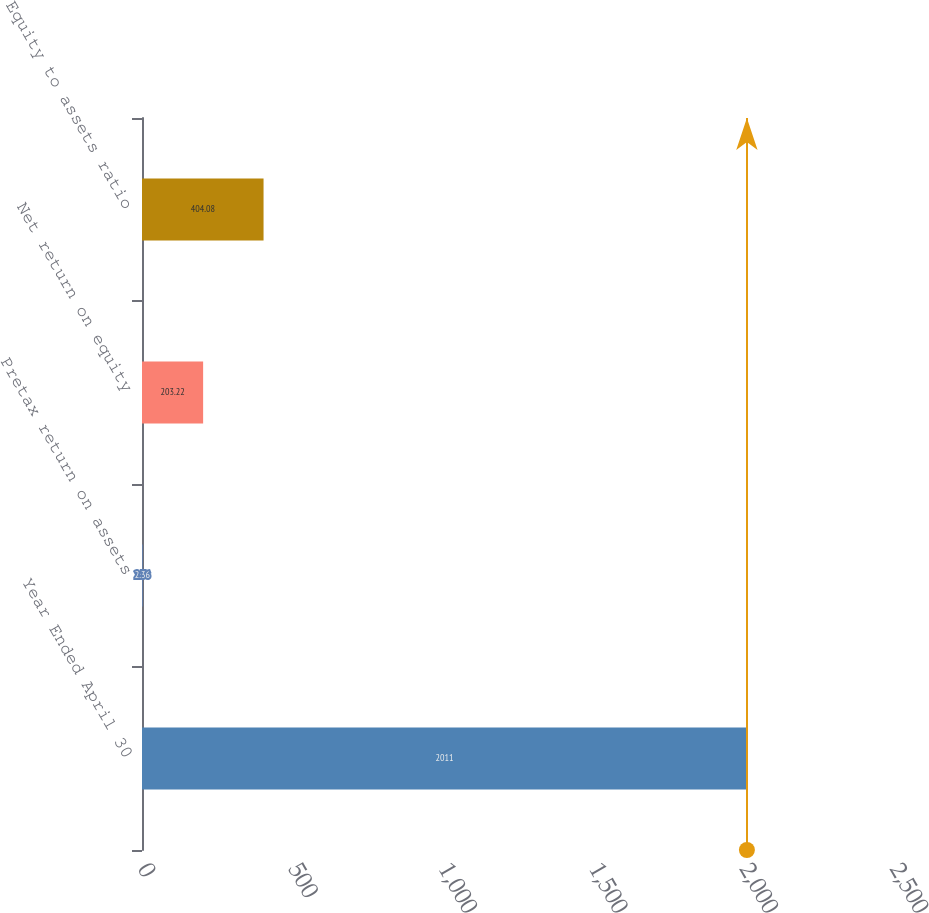Convert chart. <chart><loc_0><loc_0><loc_500><loc_500><bar_chart><fcel>Year Ended April 30<fcel>Pretax return on assets<fcel>Net return on equity<fcel>Equity to assets ratio<nl><fcel>2011<fcel>2.36<fcel>203.22<fcel>404.08<nl></chart> 